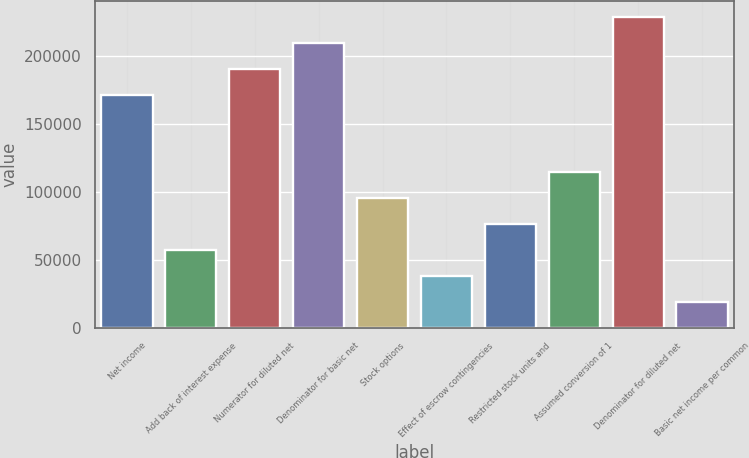<chart> <loc_0><loc_0><loc_500><loc_500><bar_chart><fcel>Net income<fcel>Add back of interest expense<fcel>Numerator for diluted net<fcel>Denominator for basic net<fcel>Stock options<fcel>Effect of escrow contingencies<fcel>Restricted stock units and<fcel>Assumed conversion of 1<fcel>Denominator for diluted net<fcel>Basic net income per common<nl><fcel>171220<fcel>57195.6<fcel>190285<fcel>209350<fcel>95325.4<fcel>38130.7<fcel>76260.5<fcel>114390<fcel>228415<fcel>19065.8<nl></chart> 